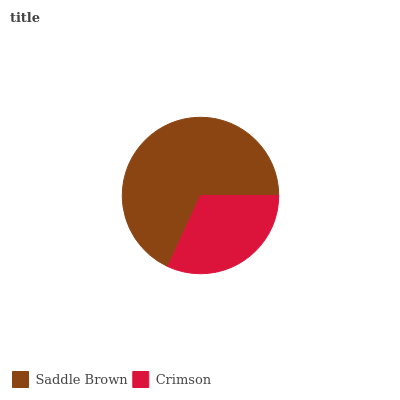Is Crimson the minimum?
Answer yes or no. Yes. Is Saddle Brown the maximum?
Answer yes or no. Yes. Is Crimson the maximum?
Answer yes or no. No. Is Saddle Brown greater than Crimson?
Answer yes or no. Yes. Is Crimson less than Saddle Brown?
Answer yes or no. Yes. Is Crimson greater than Saddle Brown?
Answer yes or no. No. Is Saddle Brown less than Crimson?
Answer yes or no. No. Is Saddle Brown the high median?
Answer yes or no. Yes. Is Crimson the low median?
Answer yes or no. Yes. Is Crimson the high median?
Answer yes or no. No. Is Saddle Brown the low median?
Answer yes or no. No. 